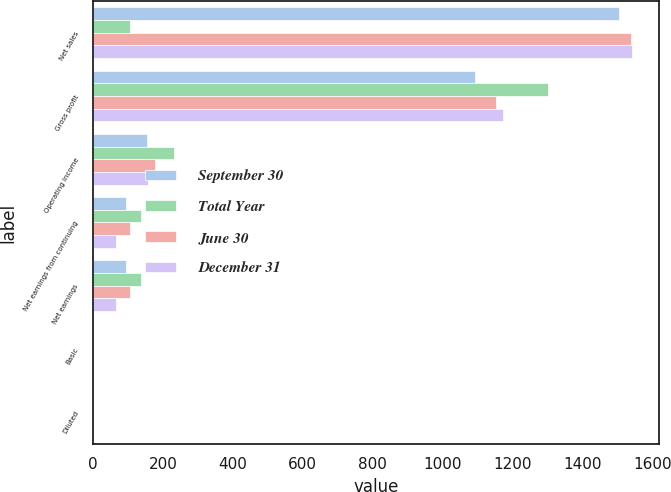Convert chart. <chart><loc_0><loc_0><loc_500><loc_500><stacked_bar_chart><ecel><fcel>Net sales<fcel>Gross profit<fcel>Operating income<fcel>Net earnings from continuing<fcel>Net earnings<fcel>Basic<fcel>Diluted<nl><fcel>September 30<fcel>1504.1<fcel>1092.8<fcel>155.3<fcel>95<fcel>95<fcel>0.42<fcel>0.41<nl><fcel>Total Year<fcel>106.2<fcel>1302.3<fcel>230.5<fcel>138.3<fcel>138.3<fcel>0.61<fcel>0.6<nl><fcel>June 30<fcel>1538.2<fcel>1151.7<fcel>176.4<fcel>106.2<fcel>106.2<fcel>0.47<fcel>0.46<nl><fcel>December 31<fcel>1543.7<fcel>1172.1<fcel>158.4<fcel>66.6<fcel>66.6<fcel>0.3<fcel>0.3<nl></chart> 